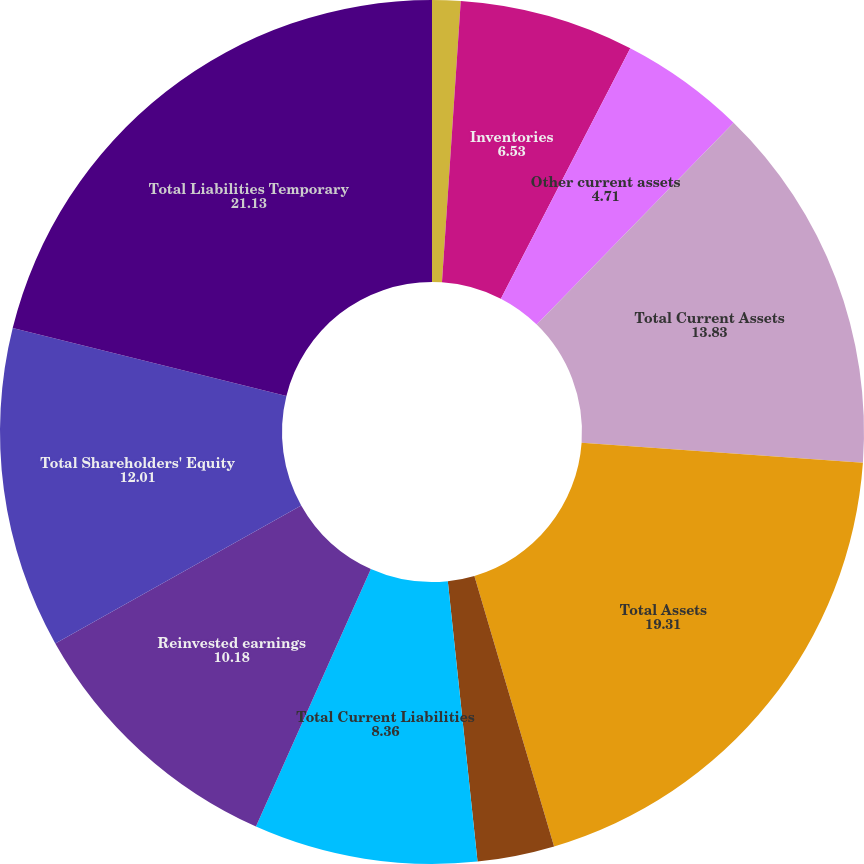Convert chart to OTSL. <chart><loc_0><loc_0><loc_500><loc_500><pie_chart><fcel>Trade receivables<fcel>Inventories<fcel>Other current assets<fcel>Total Current Assets<fcel>Total Assets<fcel>Accrued expenses and other<fcel>Total Current Liabilities<fcel>Reinvested earnings<fcel>Total Shareholders' Equity<fcel>Total Liabilities Temporary<nl><fcel>1.06%<fcel>6.53%<fcel>4.71%<fcel>13.83%<fcel>19.31%<fcel>2.88%<fcel>8.36%<fcel>10.18%<fcel>12.01%<fcel>21.13%<nl></chart> 